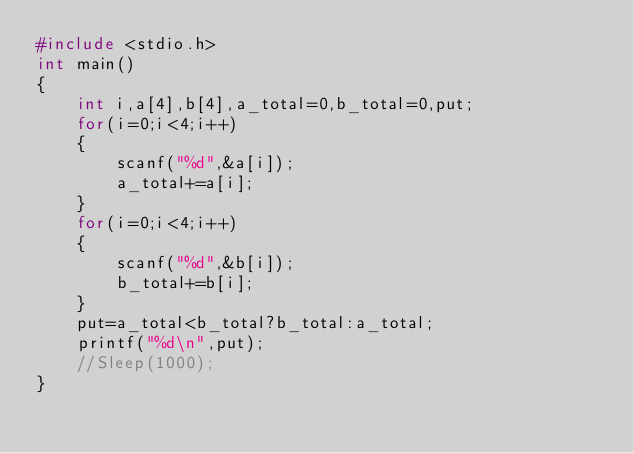Convert code to text. <code><loc_0><loc_0><loc_500><loc_500><_C_>#include <stdio.h>
int main()
{
    int i,a[4],b[4],a_total=0,b_total=0,put;
    for(i=0;i<4;i++)
    {
        scanf("%d",&a[i]);
        a_total+=a[i];
    }
    for(i=0;i<4;i++)
    {
        scanf("%d",&b[i]);
        b_total+=b[i];
    }
    put=a_total<b_total?b_total:a_total;
    printf("%d\n",put);
    //Sleep(1000);
}</code> 